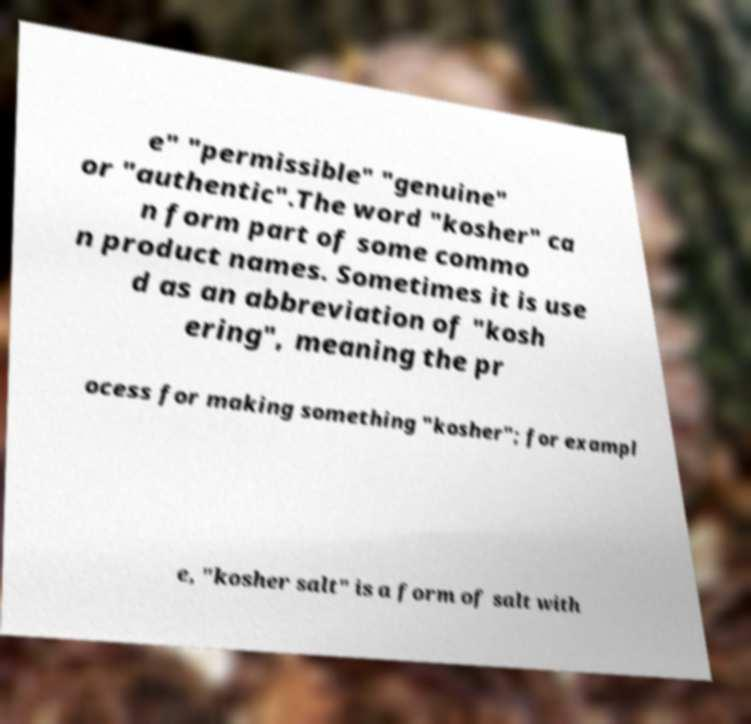Please identify and transcribe the text found in this image. e" "permissible" "genuine" or "authentic".The word "kosher" ca n form part of some commo n product names. Sometimes it is use d as an abbreviation of "kosh ering", meaning the pr ocess for making something "kosher"; for exampl e, "kosher salt" is a form of salt with 